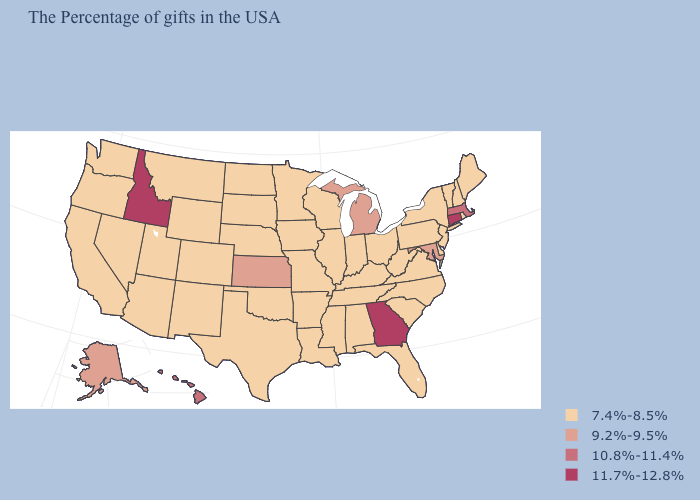Does the map have missing data?
Be succinct. No. Among the states that border New Mexico , which have the lowest value?
Be succinct. Oklahoma, Texas, Colorado, Utah, Arizona. What is the value of Delaware?
Give a very brief answer. 7.4%-8.5%. Name the states that have a value in the range 10.8%-11.4%?
Keep it brief. Massachusetts, Hawaii. What is the lowest value in states that border North Carolina?
Short answer required. 7.4%-8.5%. Does Connecticut have the highest value in the USA?
Write a very short answer. Yes. What is the value of North Dakota?
Quick response, please. 7.4%-8.5%. What is the lowest value in the USA?
Short answer required. 7.4%-8.5%. What is the value of Massachusetts?
Keep it brief. 10.8%-11.4%. Does the map have missing data?
Answer briefly. No. Which states have the lowest value in the USA?
Be succinct. Maine, Rhode Island, New Hampshire, Vermont, New York, New Jersey, Delaware, Pennsylvania, Virginia, North Carolina, South Carolina, West Virginia, Ohio, Florida, Kentucky, Indiana, Alabama, Tennessee, Wisconsin, Illinois, Mississippi, Louisiana, Missouri, Arkansas, Minnesota, Iowa, Nebraska, Oklahoma, Texas, South Dakota, North Dakota, Wyoming, Colorado, New Mexico, Utah, Montana, Arizona, Nevada, California, Washington, Oregon. Does the map have missing data?
Concise answer only. No. What is the highest value in states that border Montana?
Give a very brief answer. 11.7%-12.8%. 